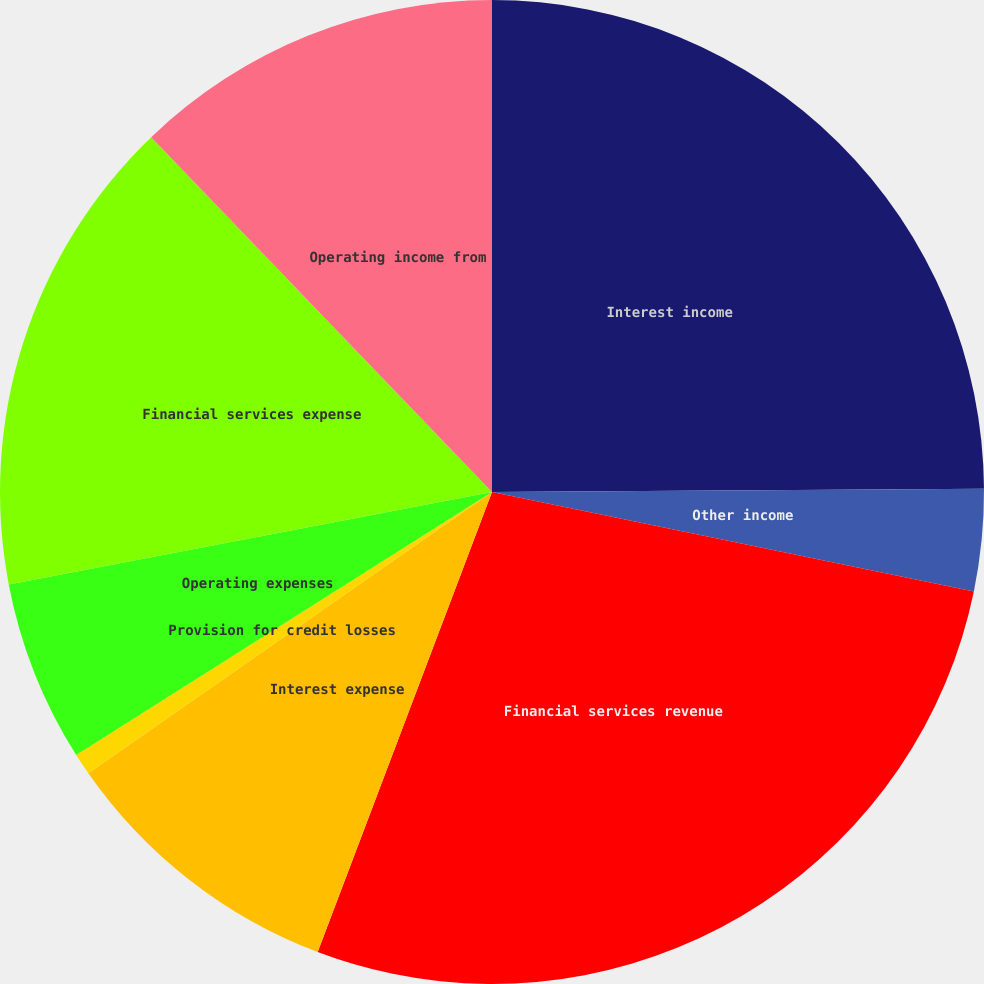Convert chart to OTSL. <chart><loc_0><loc_0><loc_500><loc_500><pie_chart><fcel>Interest income<fcel>Other income<fcel>Financial services revenue<fcel>Interest expense<fcel>Provision for credit losses<fcel>Operating expenses<fcel>Financial services expense<fcel>Operating income from<nl><fcel>24.9%<fcel>3.34%<fcel>27.53%<fcel>9.55%<fcel>0.71%<fcel>5.97%<fcel>15.83%<fcel>12.18%<nl></chart> 